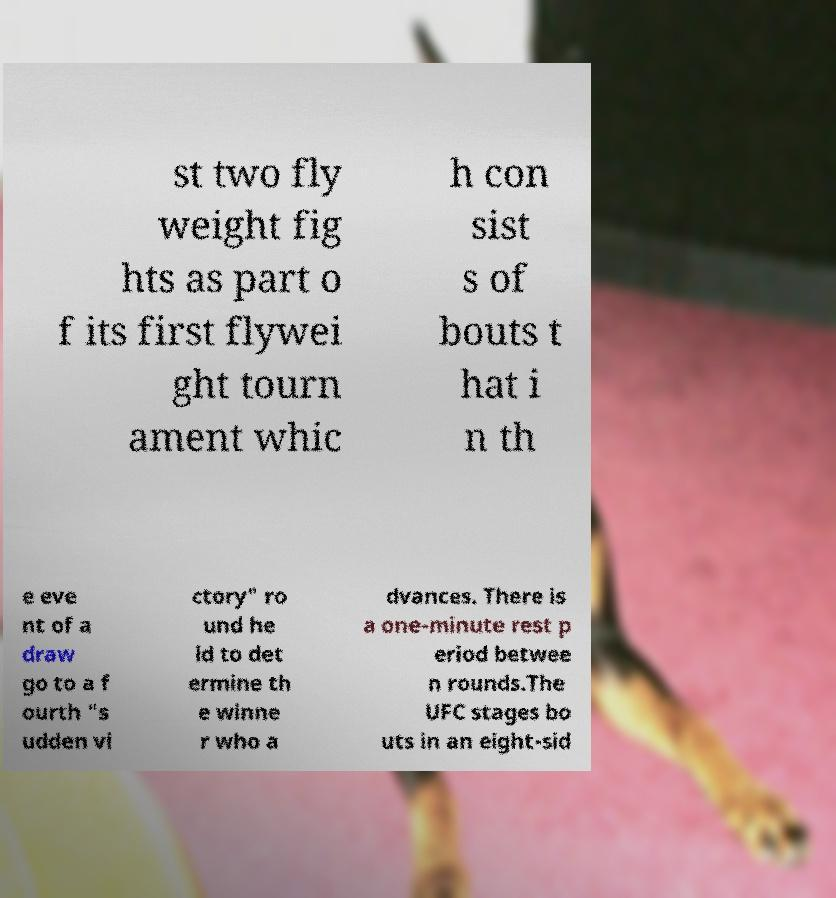Can you read and provide the text displayed in the image?This photo seems to have some interesting text. Can you extract and type it out for me? st two fly weight fig hts as part o f its first flywei ght tourn ament whic h con sist s of bouts t hat i n th e eve nt of a draw go to a f ourth "s udden vi ctory" ro und he ld to det ermine th e winne r who a dvances. There is a one-minute rest p eriod betwee n rounds.The UFC stages bo uts in an eight-sid 